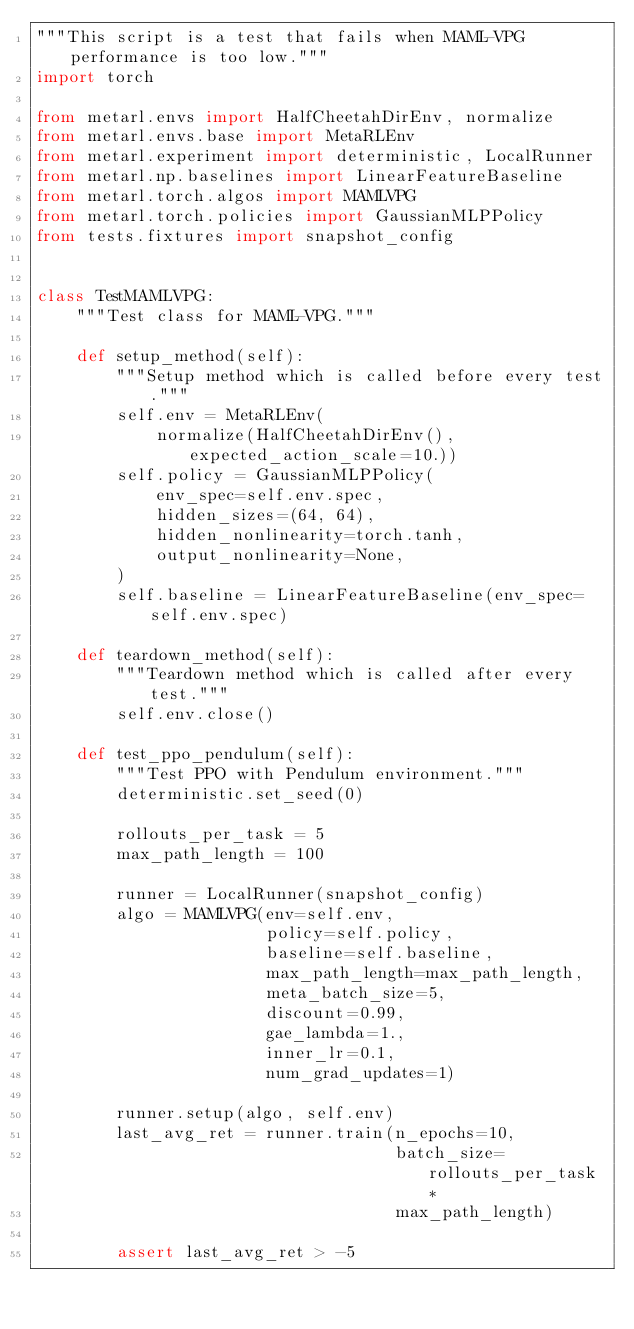Convert code to text. <code><loc_0><loc_0><loc_500><loc_500><_Python_>"""This script is a test that fails when MAML-VPG performance is too low."""
import torch

from metarl.envs import HalfCheetahDirEnv, normalize
from metarl.envs.base import MetaRLEnv
from metarl.experiment import deterministic, LocalRunner
from metarl.np.baselines import LinearFeatureBaseline
from metarl.torch.algos import MAMLVPG
from metarl.torch.policies import GaussianMLPPolicy
from tests.fixtures import snapshot_config


class TestMAMLVPG:
    """Test class for MAML-VPG."""

    def setup_method(self):
        """Setup method which is called before every test."""
        self.env = MetaRLEnv(
            normalize(HalfCheetahDirEnv(), expected_action_scale=10.))
        self.policy = GaussianMLPPolicy(
            env_spec=self.env.spec,
            hidden_sizes=(64, 64),
            hidden_nonlinearity=torch.tanh,
            output_nonlinearity=None,
        )
        self.baseline = LinearFeatureBaseline(env_spec=self.env.spec)

    def teardown_method(self):
        """Teardown method which is called after every test."""
        self.env.close()

    def test_ppo_pendulum(self):
        """Test PPO with Pendulum environment."""
        deterministic.set_seed(0)

        rollouts_per_task = 5
        max_path_length = 100

        runner = LocalRunner(snapshot_config)
        algo = MAMLVPG(env=self.env,
                       policy=self.policy,
                       baseline=self.baseline,
                       max_path_length=max_path_length,
                       meta_batch_size=5,
                       discount=0.99,
                       gae_lambda=1.,
                       inner_lr=0.1,
                       num_grad_updates=1)

        runner.setup(algo, self.env)
        last_avg_ret = runner.train(n_epochs=10,
                                    batch_size=rollouts_per_task *
                                    max_path_length)

        assert last_avg_ret > -5
</code> 